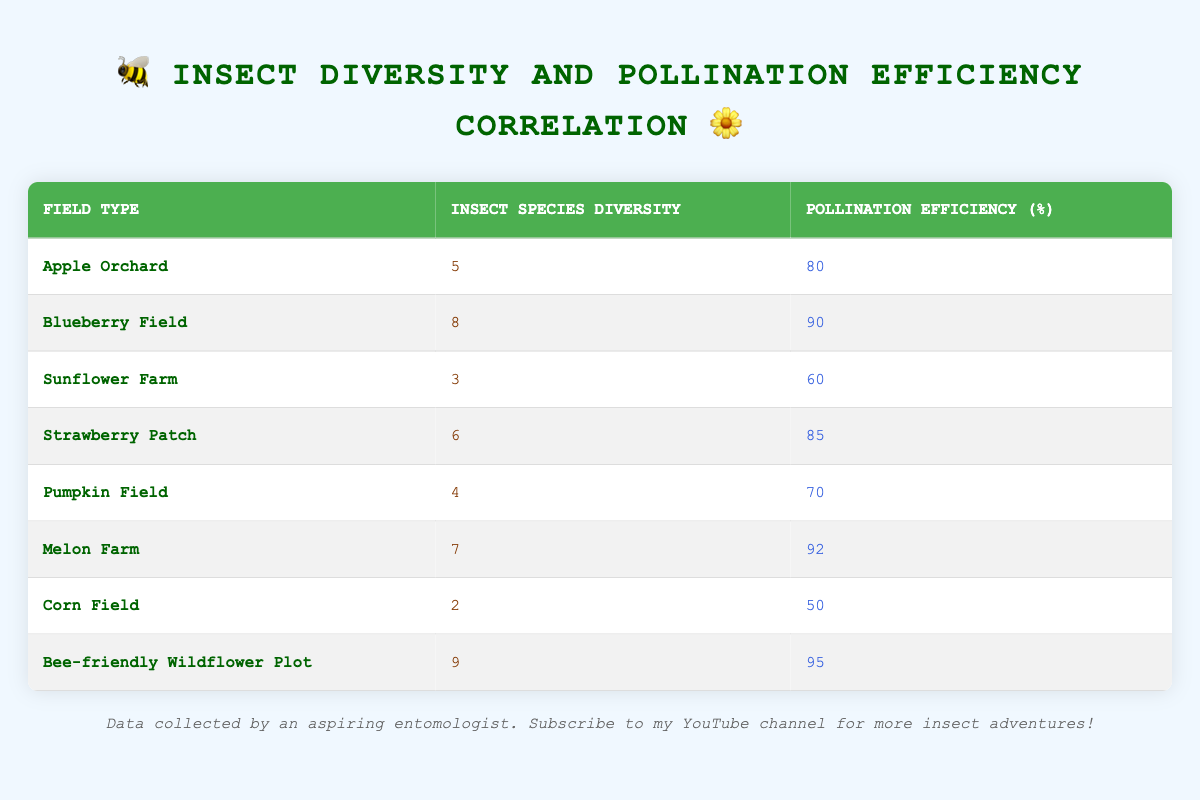What is the pollination efficiency for the Bee-friendly Wildflower Plot? The table directly lists the pollination efficiency for each field type. For the Bee-friendly Wildflower Plot, the pollination efficiency is noted as 95%.
Answer: 95 Which field type has the highest insect species diversity? By checking the insect species diversity values in the table, the highest value is found for the Bee-friendly Wildflower Plot with a diversity score of 9.
Answer: Bee-friendly Wildflower Plot What is the difference in pollination efficiency between the highest and lowest insect species diversity? The table shows that the highest insect species diversity (9) belongs to the Bee-friendly Wildflower Plot with a pollination efficiency of 95%. The lowest insect species diversity (2) belongs to the Corn Field with an efficiency of 50%. The difference is 95 - 50 = 45.
Answer: 45 What is the average pollination efficiency across all fields? To find the average, add up all the pollination efficiency values: 80 + 90 + 60 + 85 + 70 + 92 + 50 + 95 = 722. There are 8 entries, so the average is 722 / 8 = 90.25.
Answer: 90.25 Is the pollination efficiency of the Melon Farm greater than the average efficiency? From previous calculations, the average efficiency is 90.25%. For the Melon Farm, the efficiency is 92%, which is greater than 90.25%. Therefore, the statement is true.
Answer: Yes What insect species diversity corresponds to a pollination efficiency of 70%? Looking through the table, the only field with a pollination efficiency of 70% is the Pumpkin Field, which corresponds to an insect species diversity of 4.
Answer: 4 How many field types have a pollination efficiency of 85% or higher? First, we note the fields with efficiencies of 85%, 90%, and 95%. Those field types are: Blueberry Field, Strawberry Patch, Melon Farm, and Bee-friendly Wildflower Plot. This gives us a total of 4 fields.
Answer: 4 Which field type has the lowest pollination efficiency? The table shows that the Corn Field has the lowest pollination efficiency, which is recorded as 50%.
Answer: Corn Field 